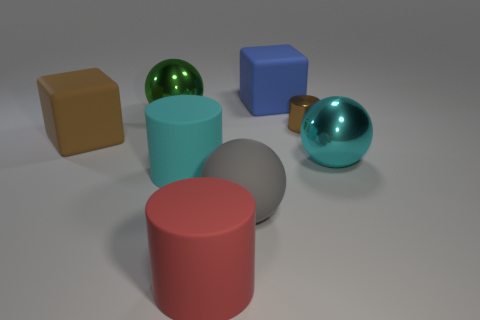Subtract all tiny brown cylinders. How many cylinders are left? 2 Subtract all cyan cylinders. How many cylinders are left? 2 Subtract 2 cylinders. How many cylinders are left? 1 Subtract all cylinders. How many objects are left? 5 Subtract all purple spheres. How many gray cylinders are left? 0 Add 1 large cylinders. How many objects exist? 9 Add 3 large metal spheres. How many large metal spheres are left? 5 Add 7 blue rubber spheres. How many blue rubber spheres exist? 7 Subtract 0 yellow balls. How many objects are left? 8 Subtract all green cubes. Subtract all gray cylinders. How many cubes are left? 2 